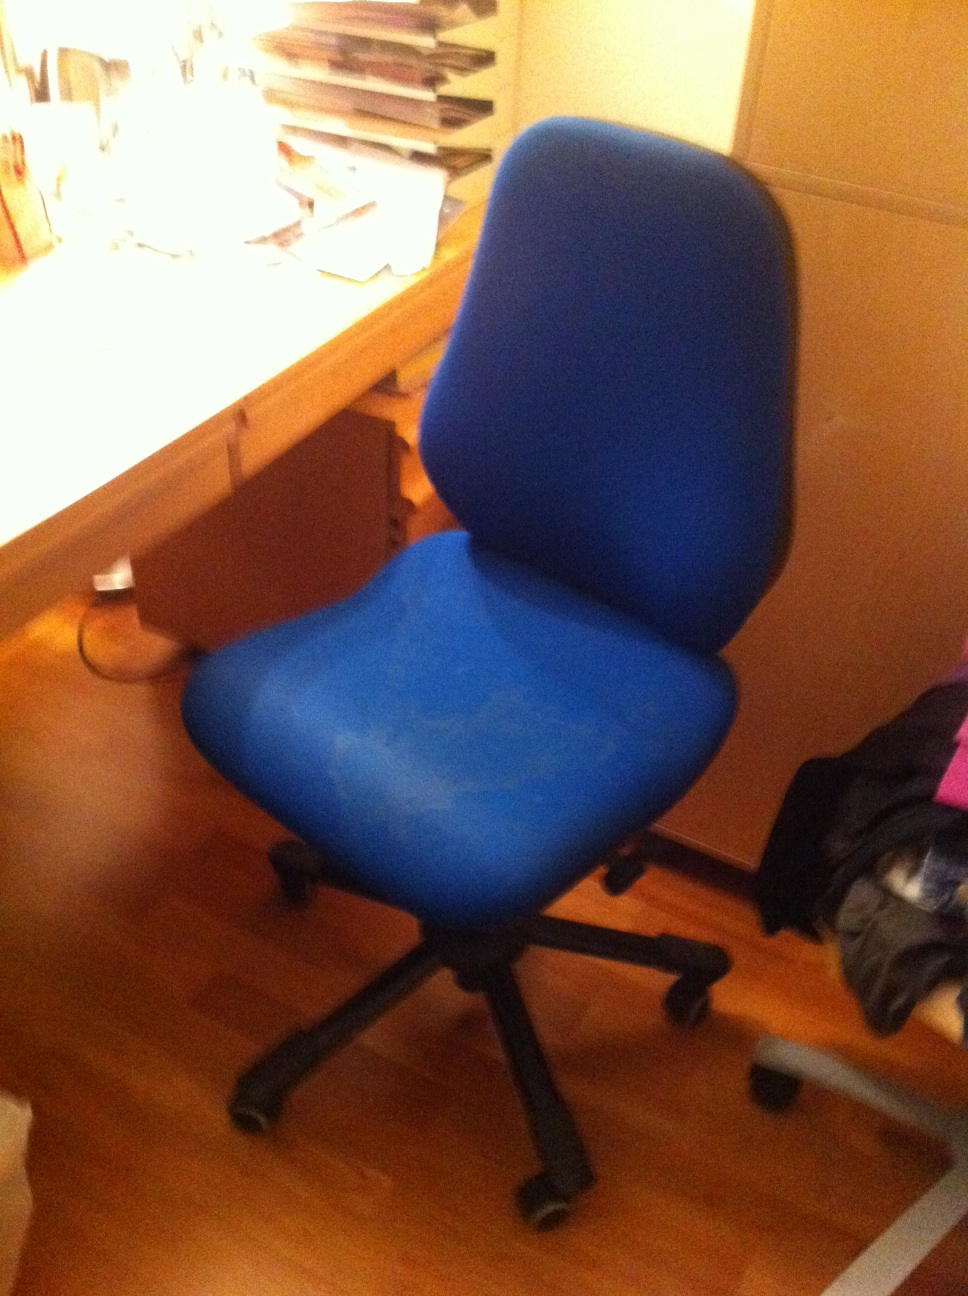Considering the items on the desk, what sort of tasks is the person using this chair likely working on? Based on the items visible on the desk, such as stacks of papers and folders, it looks like the person using this chair is likely engaged in tasks that involve a good amount of paperwork and organization. These could include studying, working on administrative tasks, preparing reports or presentations, or handling correspondence and data entry. The presence of a lamp suggests they may also be working late into the evening or in need of focused lighting for reading and detailed work. Create a fictional short story where this chair plays a central role. In a small, cozy home office tucked away in the corner of a house, there stood a blue office chair named Blue. Blue was not just an ordinary chair; it had a hidden gift - the enchantment to bring creativity and inspiration to anyone who sat on it. One day, a struggling writer named Emma moved into the house and found Blue. Not knowing its magical properties, she chose Blue because it looked comfortable and sturdy. Desperate to overcome her writer's block, Emma spent hours each day sitting on Blue, staring at the blank pages and piles of notes on her desk. Gradually, she began to notice something extraordinary. Whenever she sat on Blue, ideas flowed more freely, her fingers danced across the keyboard with ease, and words seemed to materialize out of thin air. She wrote short stories, poetry, and even started her first novel. As weeks turned into months, Emma's work flourished. She sent out her stories, and to her delight, they were published to great acclaim. Blue's magic was working, infusing every word with a touch of brilliance. Emma's once dreary home office transformed into a sanctuary of creativity. One evening, she discovered an old journal tucked beneath a stack of papers. In it, she found a note from the previous owner of the house, revealing the secret of Blue's enchantment and how it had inspired generations of artists, writers, and thinkers. Emma realized how fortunate she was to have found such a special chair and vowed to cherish Blue for the rest of her writing journey. Blue, ever faithful, continued to support Emma, not just physically but also as the silent muse that turned her dreams into words, helping her achieve success beyond her wildest imaginings. 